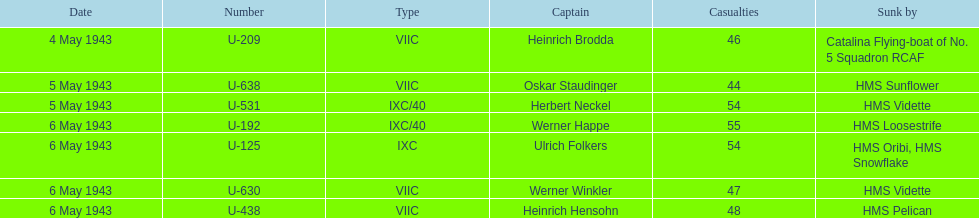Which was the only captain brought down by hms pelican? Heinrich Hensohn. 